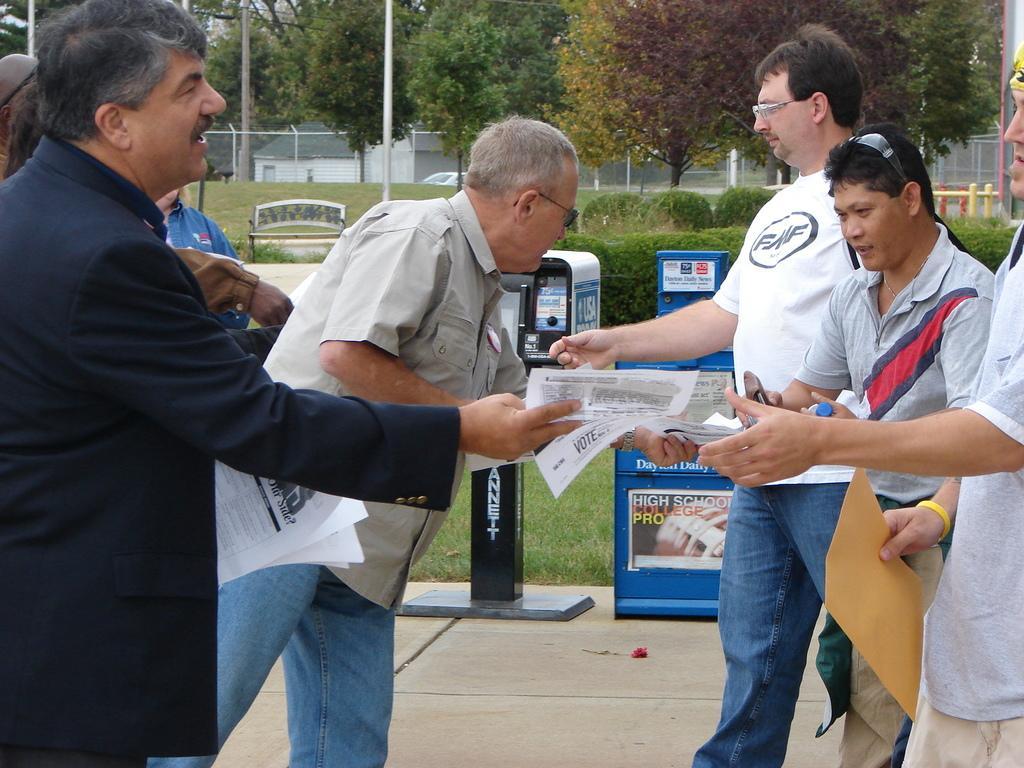Can you describe this image briefly? This picture describes about group of people, they are all standing, and they are holding papers, beside to them we can see few machines, in the background we can find few shrubs, trees, poles, houses and a bench. 